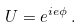<formula> <loc_0><loc_0><loc_500><loc_500>U = e ^ { i e \phi } \, .</formula> 